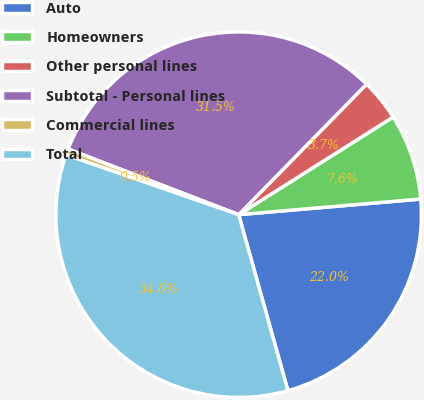Convert chart to OTSL. <chart><loc_0><loc_0><loc_500><loc_500><pie_chart><fcel>Auto<fcel>Homeowners<fcel>Other personal lines<fcel>Subtotal - Personal lines<fcel>Commercial lines<fcel>Total<nl><fcel>22.02%<fcel>7.61%<fcel>3.69%<fcel>31.49%<fcel>0.54%<fcel>34.64%<nl></chart> 